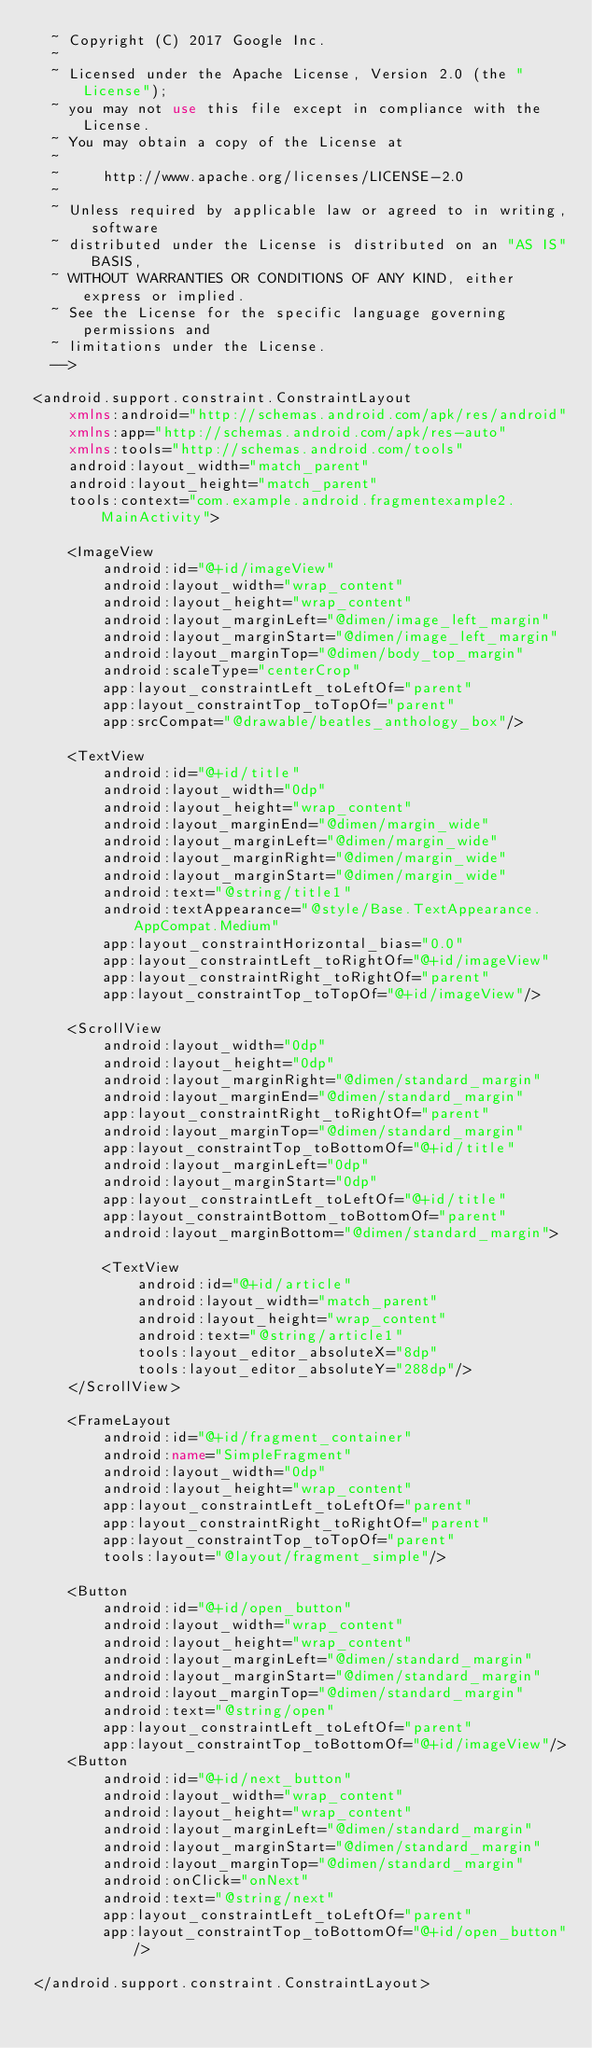Convert code to text. <code><loc_0><loc_0><loc_500><loc_500><_XML_>  ~ Copyright (C) 2017 Google Inc.
  ~
  ~ Licensed under the Apache License, Version 2.0 (the "License");
  ~ you may not use this file except in compliance with the License.
  ~ You may obtain a copy of the License at
  ~
  ~     http://www.apache.org/licenses/LICENSE-2.0
  ~
  ~ Unless required by applicable law or agreed to in writing, software
  ~ distributed under the License is distributed on an "AS IS" BASIS,
  ~ WITHOUT WARRANTIES OR CONDITIONS OF ANY KIND, either express or implied.
  ~ See the License for the specific language governing permissions and
  ~ limitations under the License.
  -->

<android.support.constraint.ConstraintLayout
    xmlns:android="http://schemas.android.com/apk/res/android"
    xmlns:app="http://schemas.android.com/apk/res-auto"
    xmlns:tools="http://schemas.android.com/tools"
    android:layout_width="match_parent"
    android:layout_height="match_parent"
    tools:context="com.example.android.fragmentexample2.MainActivity">

    <ImageView
        android:id="@+id/imageView"
        android:layout_width="wrap_content"
        android:layout_height="wrap_content"
        android:layout_marginLeft="@dimen/image_left_margin"
        android:layout_marginStart="@dimen/image_left_margin"
        android:layout_marginTop="@dimen/body_top_margin"
        android:scaleType="centerCrop"
        app:layout_constraintLeft_toLeftOf="parent"
        app:layout_constraintTop_toTopOf="parent"
        app:srcCompat="@drawable/beatles_anthology_box"/>

    <TextView
        android:id="@+id/title"
        android:layout_width="0dp"
        android:layout_height="wrap_content"
        android:layout_marginEnd="@dimen/margin_wide"
        android:layout_marginLeft="@dimen/margin_wide"
        android:layout_marginRight="@dimen/margin_wide"
        android:layout_marginStart="@dimen/margin_wide"
        android:text="@string/title1"
        android:textAppearance="@style/Base.TextAppearance.AppCompat.Medium"
        app:layout_constraintHorizontal_bias="0.0"
        app:layout_constraintLeft_toRightOf="@+id/imageView"
        app:layout_constraintRight_toRightOf="parent"
        app:layout_constraintTop_toTopOf="@+id/imageView"/>

    <ScrollView
        android:layout_width="0dp"
        android:layout_height="0dp"
        android:layout_marginRight="@dimen/standard_margin"
        android:layout_marginEnd="@dimen/standard_margin"
        app:layout_constraintRight_toRightOf="parent"
        android:layout_marginTop="@dimen/standard_margin"
        app:layout_constraintTop_toBottomOf="@+id/title"
        android:layout_marginLeft="0dp"
        android:layout_marginStart="0dp"
        app:layout_constraintLeft_toLeftOf="@+id/title"
        app:layout_constraintBottom_toBottomOf="parent"
        android:layout_marginBottom="@dimen/standard_margin">

        <TextView
            android:id="@+id/article"
            android:layout_width="match_parent"
            android:layout_height="wrap_content"
            android:text="@string/article1"
            tools:layout_editor_absoluteX="8dp"
            tools:layout_editor_absoluteY="288dp"/>
    </ScrollView>

    <FrameLayout
        android:id="@+id/fragment_container"
        android:name="SimpleFragment"
        android:layout_width="0dp"
        android:layout_height="wrap_content"
        app:layout_constraintLeft_toLeftOf="parent"
        app:layout_constraintRight_toRightOf="parent"
        app:layout_constraintTop_toTopOf="parent"
        tools:layout="@layout/fragment_simple"/>

    <Button
        android:id="@+id/open_button"
        android:layout_width="wrap_content"
        android:layout_height="wrap_content"
        android:layout_marginLeft="@dimen/standard_margin"
        android:layout_marginStart="@dimen/standard_margin"
        android:layout_marginTop="@dimen/standard_margin"
        android:text="@string/open"
        app:layout_constraintLeft_toLeftOf="parent"
        app:layout_constraintTop_toBottomOf="@+id/imageView"/>
    <Button
        android:id="@+id/next_button"
        android:layout_width="wrap_content"
        android:layout_height="wrap_content"
        android:layout_marginLeft="@dimen/standard_margin"
        android:layout_marginStart="@dimen/standard_margin"
        android:layout_marginTop="@dimen/standard_margin"
        android:onClick="onNext"
        android:text="@string/next"
        app:layout_constraintLeft_toLeftOf="parent"
        app:layout_constraintTop_toBottomOf="@+id/open_button"/>

</android.support.constraint.ConstraintLayout>
</code> 